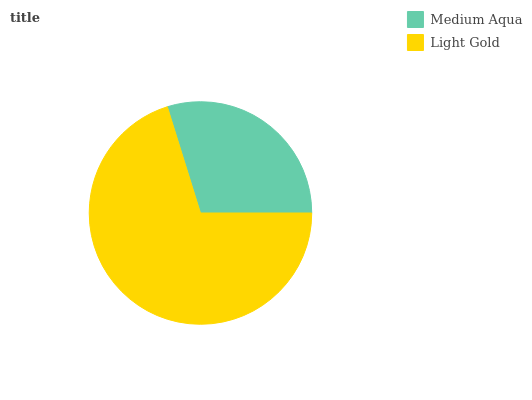Is Medium Aqua the minimum?
Answer yes or no. Yes. Is Light Gold the maximum?
Answer yes or no. Yes. Is Light Gold the minimum?
Answer yes or no. No. Is Light Gold greater than Medium Aqua?
Answer yes or no. Yes. Is Medium Aqua less than Light Gold?
Answer yes or no. Yes. Is Medium Aqua greater than Light Gold?
Answer yes or no. No. Is Light Gold less than Medium Aqua?
Answer yes or no. No. Is Light Gold the high median?
Answer yes or no. Yes. Is Medium Aqua the low median?
Answer yes or no. Yes. Is Medium Aqua the high median?
Answer yes or no. No. Is Light Gold the low median?
Answer yes or no. No. 